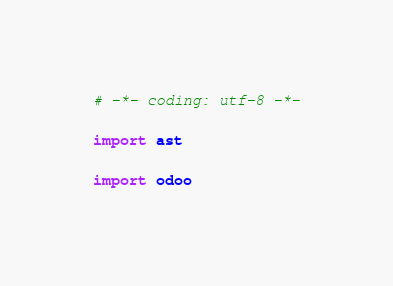Convert code to text. <code><loc_0><loc_0><loc_500><loc_500><_Python_># -*- coding: utf-8 -*-

import ast

import odoo</code> 